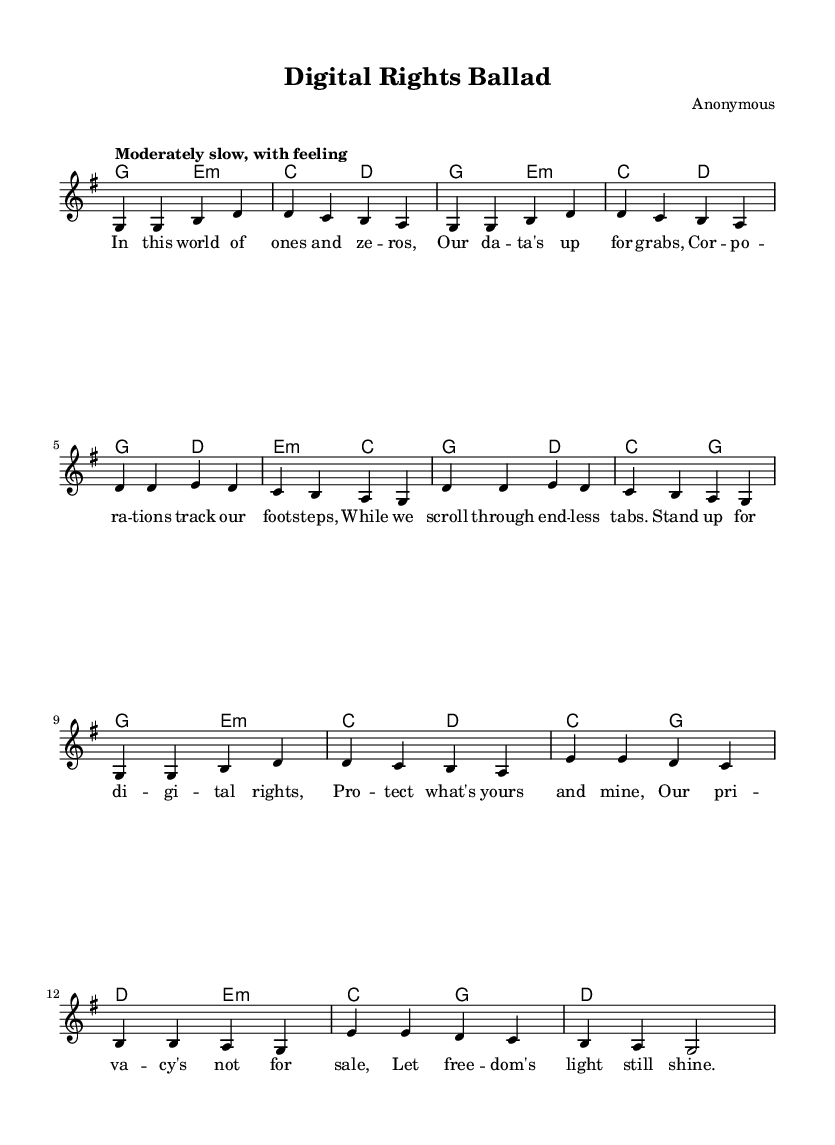What is the key signature of this music? The key signature is indicated at the beginning of the score, where there are no sharps or flats shown, identifying it as G major.
Answer: G major What is the time signature of this music? The time signature is located at the beginning of the score, represented by the fraction 4/4, which means there are four beats in each measure.
Answer: 4/4 What is the tempo marking for this piece? The tempo marking is found at the beginning of the score, stating “Moderately slow, with feeling,” which guides the performer on the speed and style of play.
Answer: Moderately slow, with feeling How many verses are included in the song? By examining the lyrics section, it shows there are two distinct parts labeled as verse; the first verse is titled "Verse" and the second one is "Verse 2 (abbreviated)," indicating two verses total.
Answer: Two What themes are addressed in the lyrics? The lyrics convey themes related to issues of data privacy and cybersecurity, highlighting concerns over surveillance, corporate control, and the need for digital rights protection.
Answer: Data privacy and cybersecurity What is the main message of the chorus? The chorus emphasizes the importance of standing up for digital rights and protecting privacy, encapsulating a call for freedom and resistance against exploitation.
Answer: Protect what's yours and mine What type of musical form does this song follow? The song follows a folk structure, featuring verses and a repeating chorus, typical of many traditional folk songs which often address social issues and personal storytelling.
Answer: Folk structure 